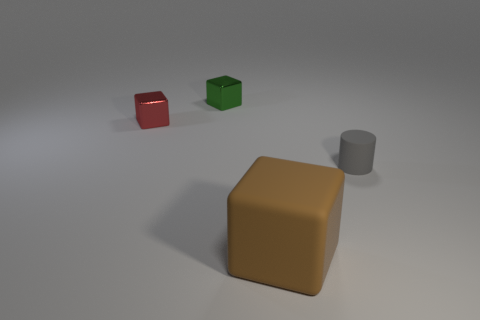Subtract all small cubes. How many cubes are left? 1 Subtract 1 blocks. How many blocks are left? 2 Add 3 green cubes. How many objects exist? 7 Subtract all cylinders. How many objects are left? 3 Subtract all metal cubes. Subtract all green things. How many objects are left? 1 Add 4 small red things. How many small red things are left? 5 Add 3 rubber cylinders. How many rubber cylinders exist? 4 Subtract 0 blue cylinders. How many objects are left? 4 